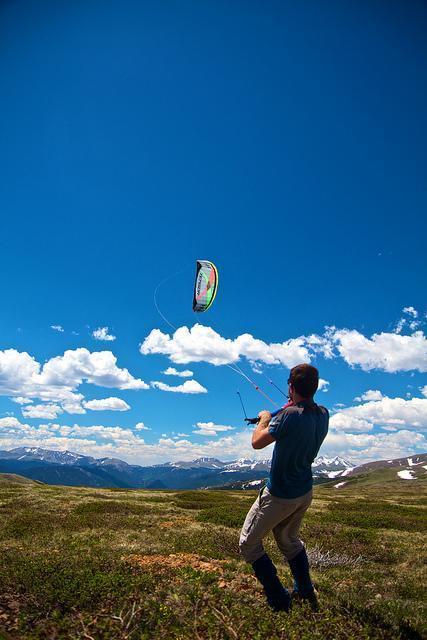How many kites are in the sky?
Give a very brief answer. 1. How many kites is this person flying?
Give a very brief answer. 1. 